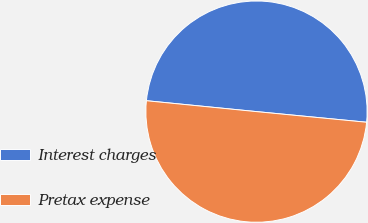Convert chart. <chart><loc_0><loc_0><loc_500><loc_500><pie_chart><fcel>Interest charges<fcel>Pretax expense<nl><fcel>49.96%<fcel>50.04%<nl></chart> 